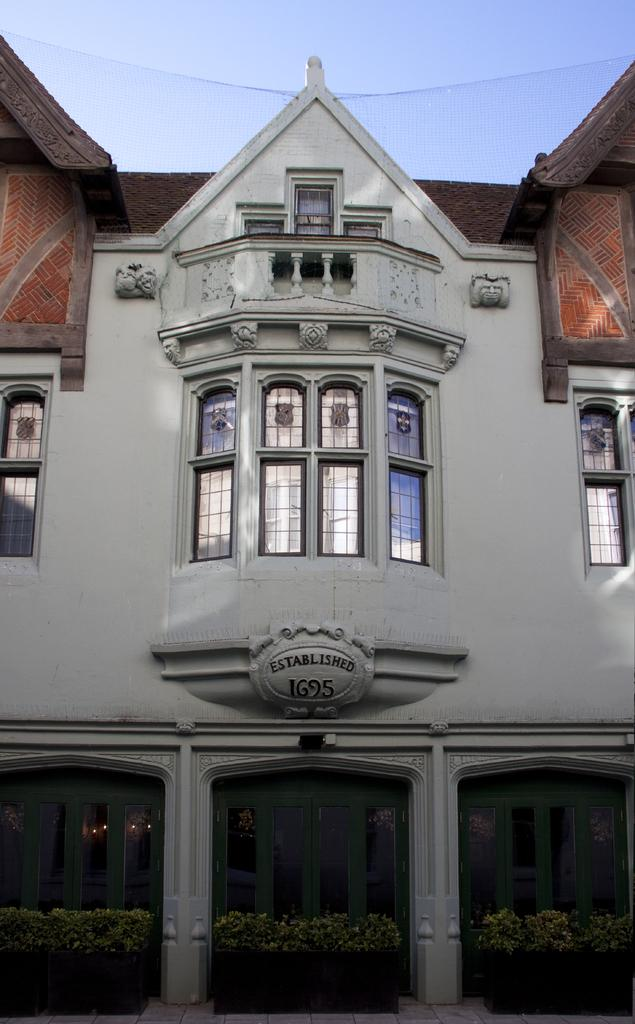What is the main subject in the center of the image? There is a house in the center of the image. What can be seen at the bottom side of the image? There are plants at the bottom side of the image. What feature does the house have? The house has windows. How many cakes are being twisted in the image? There are no cakes or twisting actions present in the image. 